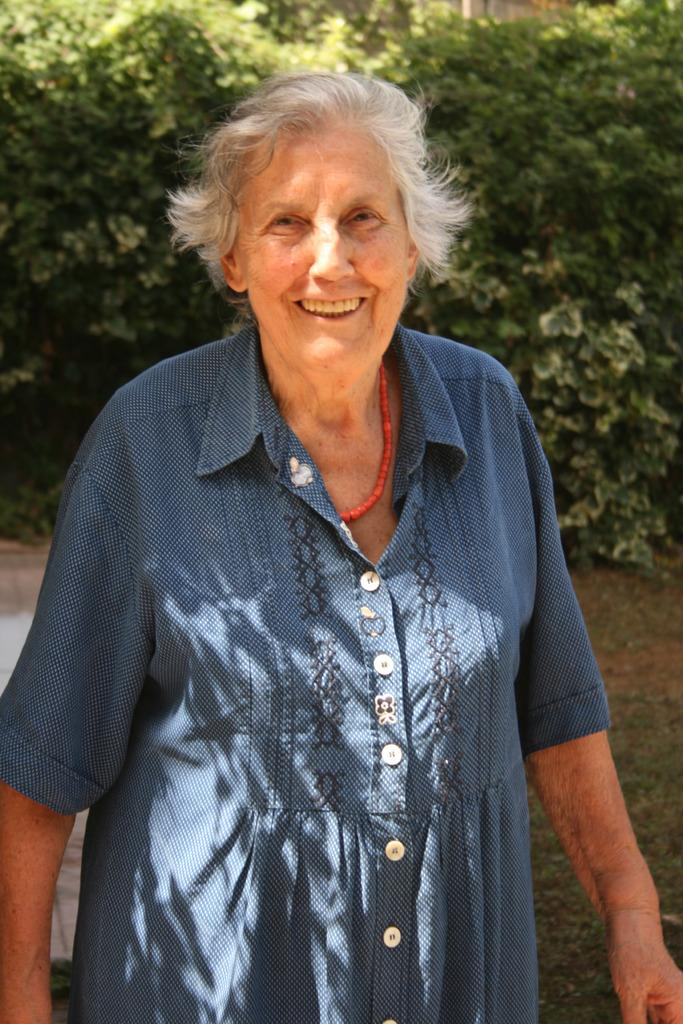Who is present in the image? There is a woman in the image. What is the woman wearing? The woman is wearing a blue dress. What can be seen in the background of the image? There are plants visible in the background of the image. What type of sign is the woman holding in the image? There is no sign present in the image; the woman is not holding anything. 